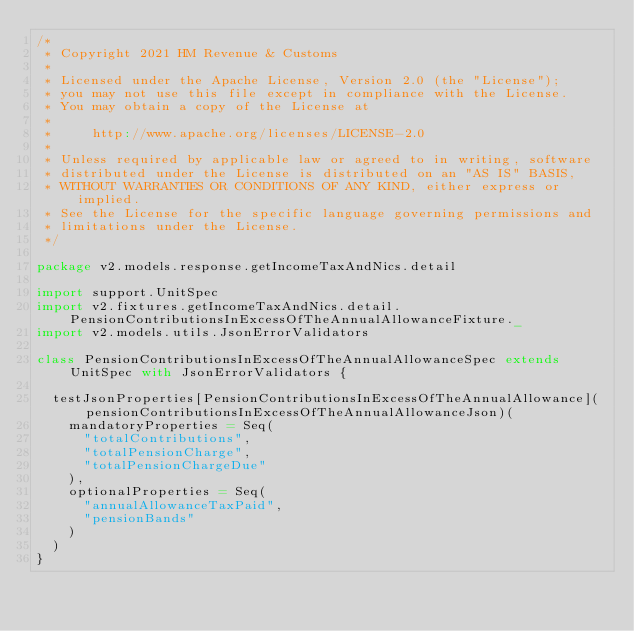Convert code to text. <code><loc_0><loc_0><loc_500><loc_500><_Scala_>/*
 * Copyright 2021 HM Revenue & Customs
 *
 * Licensed under the Apache License, Version 2.0 (the "License");
 * you may not use this file except in compliance with the License.
 * You may obtain a copy of the License at
 *
 *     http://www.apache.org/licenses/LICENSE-2.0
 *
 * Unless required by applicable law or agreed to in writing, software
 * distributed under the License is distributed on an "AS IS" BASIS,
 * WITHOUT WARRANTIES OR CONDITIONS OF ANY KIND, either express or implied.
 * See the License for the specific language governing permissions and
 * limitations under the License.
 */

package v2.models.response.getIncomeTaxAndNics.detail

import support.UnitSpec
import v2.fixtures.getIncomeTaxAndNics.detail.PensionContributionsInExcessOfTheAnnualAllowanceFixture._
import v2.models.utils.JsonErrorValidators

class PensionContributionsInExcessOfTheAnnualAllowanceSpec extends UnitSpec with JsonErrorValidators {

  testJsonProperties[PensionContributionsInExcessOfTheAnnualAllowance](pensionContributionsInExcessOfTheAnnualAllowanceJson)(
    mandatoryProperties = Seq(
      "totalContributions",
      "totalPensionCharge",
      "totalPensionChargeDue"
    ),
    optionalProperties = Seq(
      "annualAllowanceTaxPaid",
      "pensionBands"
    )
  )
}</code> 